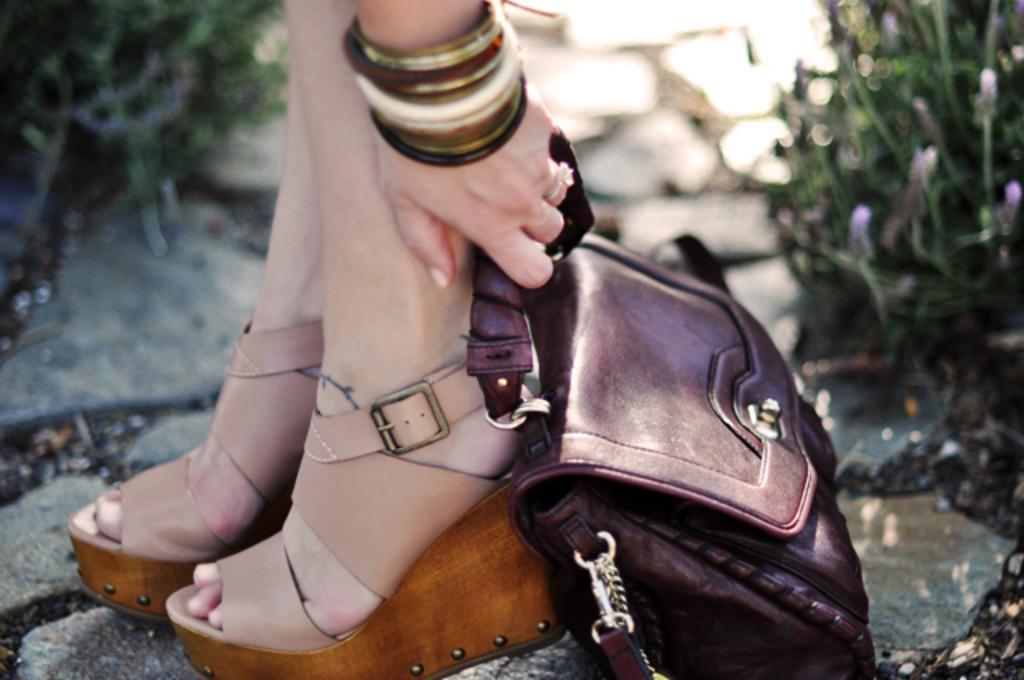Can you describe this image briefly? In this image, in the middle, we can see the legs of a person with high hills chapel. In the middle, we can also see the hand of a person holding a handbag. On the right side, we can see some plants with flowers. On the left side, we can also see some plants. At the bottom, we can see a land. 